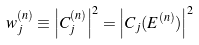<formula> <loc_0><loc_0><loc_500><loc_500>w _ { j } ^ { ( n ) } \equiv \left | C _ { j } ^ { ( n ) } \right | ^ { 2 } = \left | C _ { j } ( E ^ { ( n ) } ) \right | ^ { 2 }</formula> 